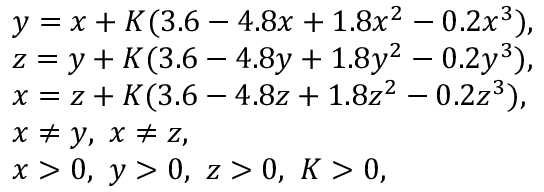<formula> <loc_0><loc_0><loc_500><loc_500>\begin{array} { r l } & { y = x + K ( 3 . 6 - 4 . 8 x + 1 . 8 x ^ { 2 } - 0 . 2 x ^ { 3 } ) , } \\ & { z = y + K ( 3 . 6 - 4 . 8 y + 1 . 8 y ^ { 2 } - 0 . 2 y ^ { 3 } ) , } \\ & { x = z + K ( 3 . 6 - 4 . 8 z + 1 . 8 z ^ { 2 } - 0 . 2 z ^ { 3 } ) , } \\ & { x \neq y , x \neq z , } \\ & { x > 0 , y > 0 , z > 0 , K > 0 , } \end{array}</formula> 